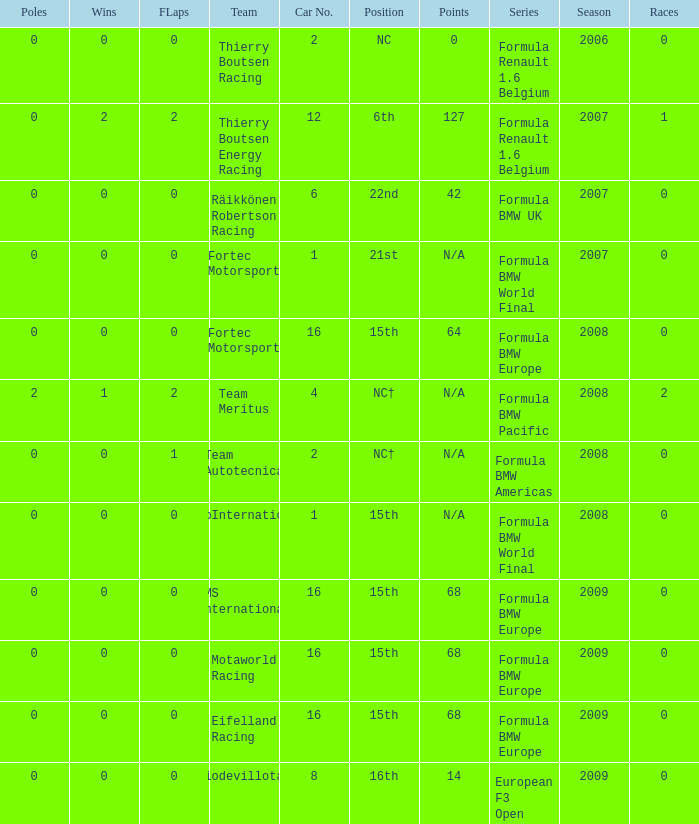Name the most poles for 64 points 0.0. 